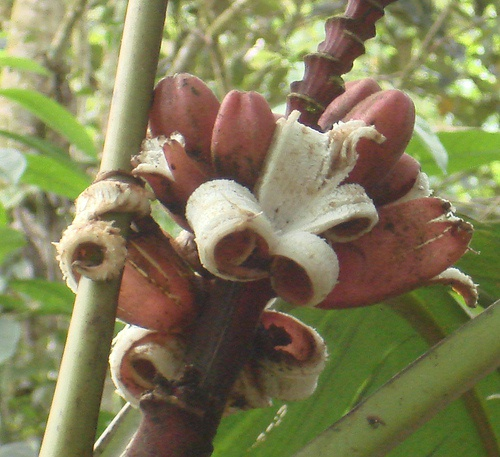Describe the objects in this image and their specific colors. I can see a banana in tan, maroon, brown, and black tones in this image. 